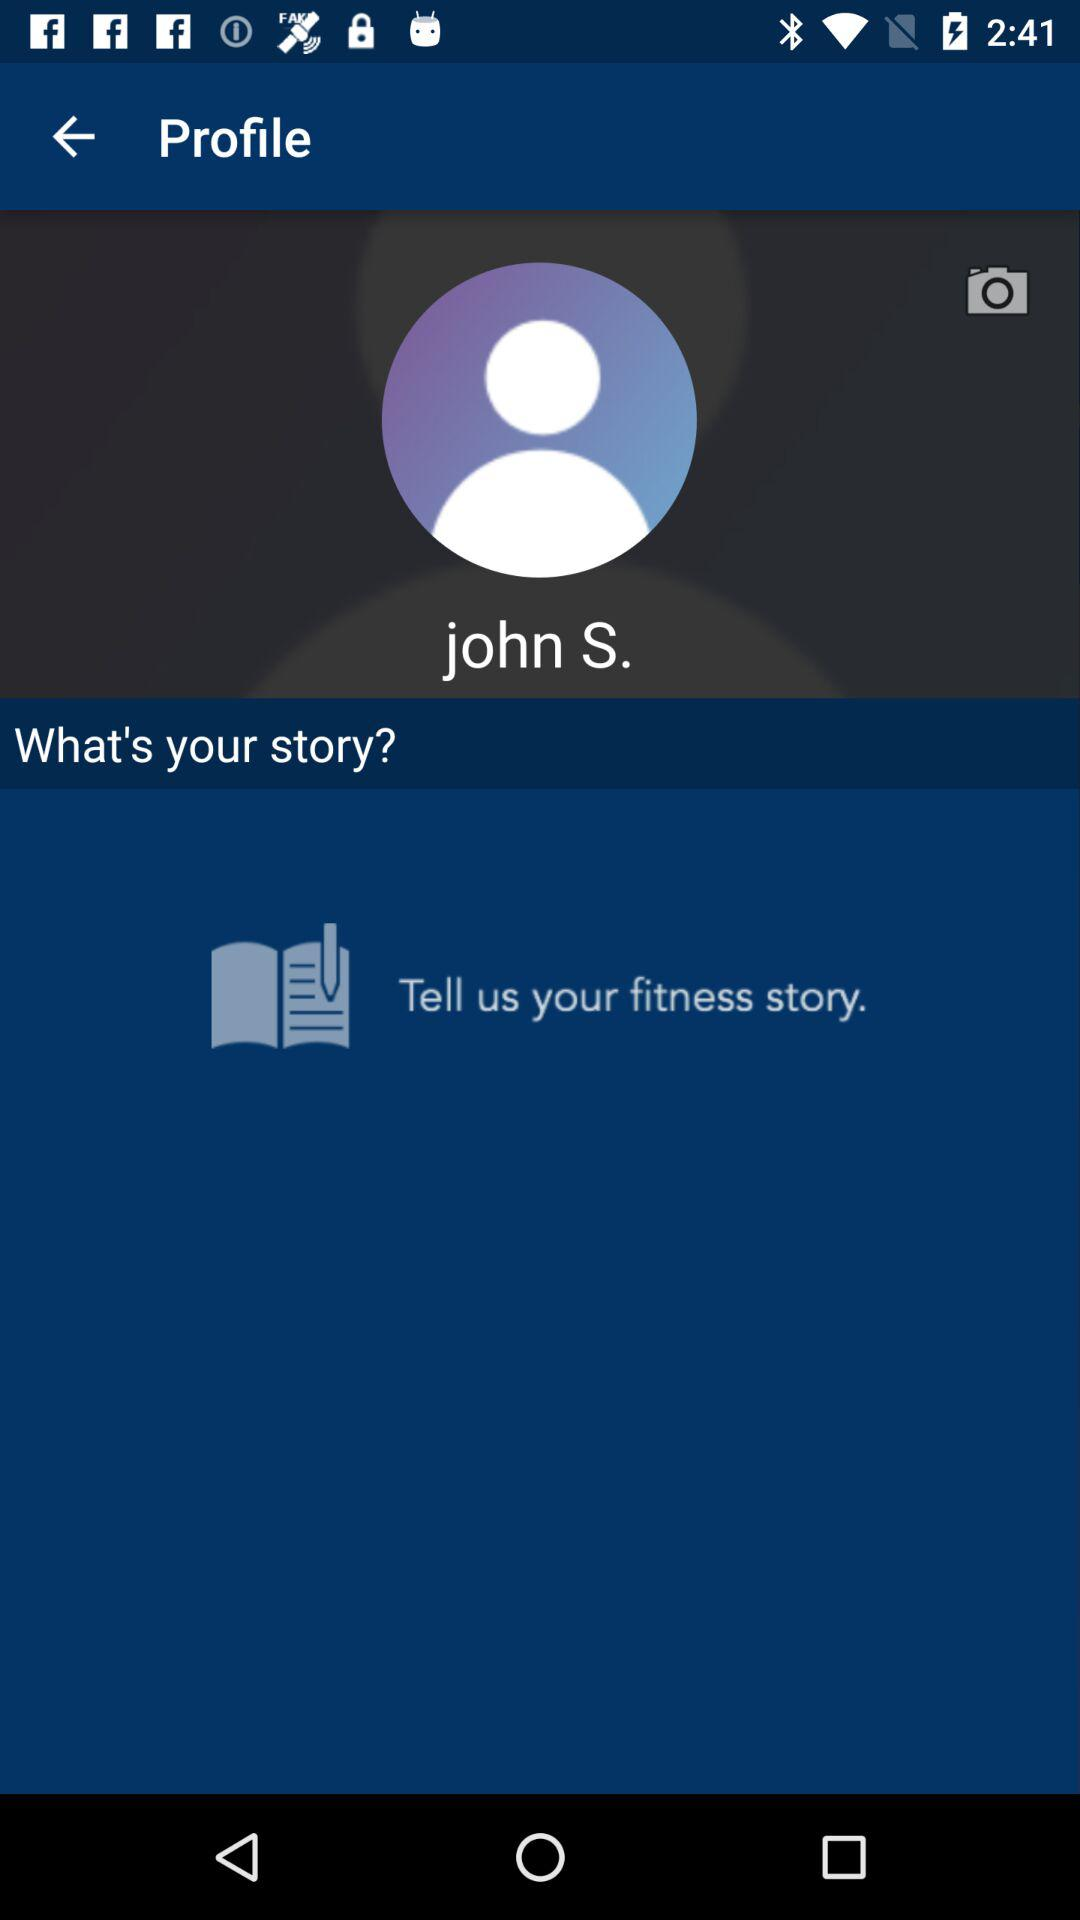What is the user name? The user name is John S. 